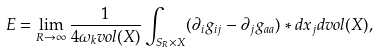Convert formula to latex. <formula><loc_0><loc_0><loc_500><loc_500>E = \lim _ { R \rightarrow \infty } \frac { 1 } { 4 \omega _ { k } v o l ( X ) } \int _ { S _ { R } \times X } ( \partial _ { i } g _ { i j } - \partial _ { j } g _ { a a } ) * d x _ { j } d v o l ( X ) ,</formula> 